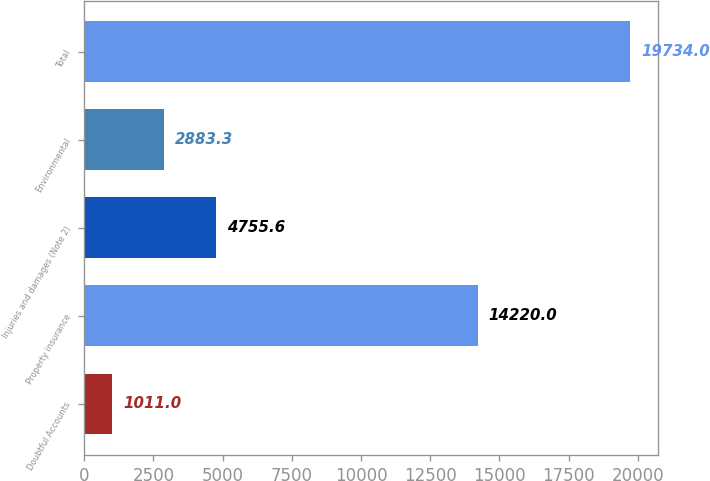Convert chart to OTSL. <chart><loc_0><loc_0><loc_500><loc_500><bar_chart><fcel>Doubtful Accounts<fcel>Property insurance<fcel>Injuries and damages (Note 2)<fcel>Environmental<fcel>Total<nl><fcel>1011<fcel>14220<fcel>4755.6<fcel>2883.3<fcel>19734<nl></chart> 